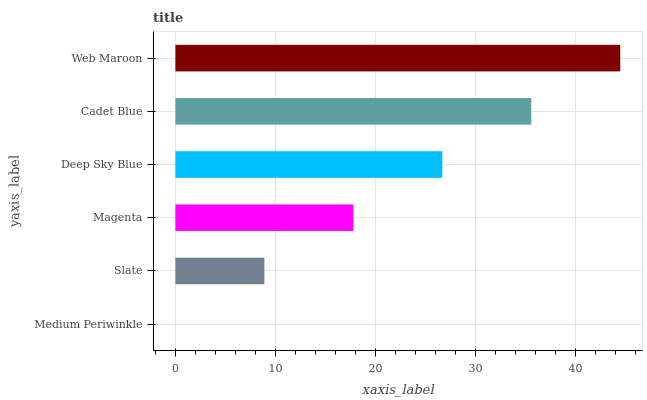Is Medium Periwinkle the minimum?
Answer yes or no. Yes. Is Web Maroon the maximum?
Answer yes or no. Yes. Is Slate the minimum?
Answer yes or no. No. Is Slate the maximum?
Answer yes or no. No. Is Slate greater than Medium Periwinkle?
Answer yes or no. Yes. Is Medium Periwinkle less than Slate?
Answer yes or no. Yes. Is Medium Periwinkle greater than Slate?
Answer yes or no. No. Is Slate less than Medium Periwinkle?
Answer yes or no. No. Is Deep Sky Blue the high median?
Answer yes or no. Yes. Is Magenta the low median?
Answer yes or no. Yes. Is Web Maroon the high median?
Answer yes or no. No. Is Deep Sky Blue the low median?
Answer yes or no. No. 